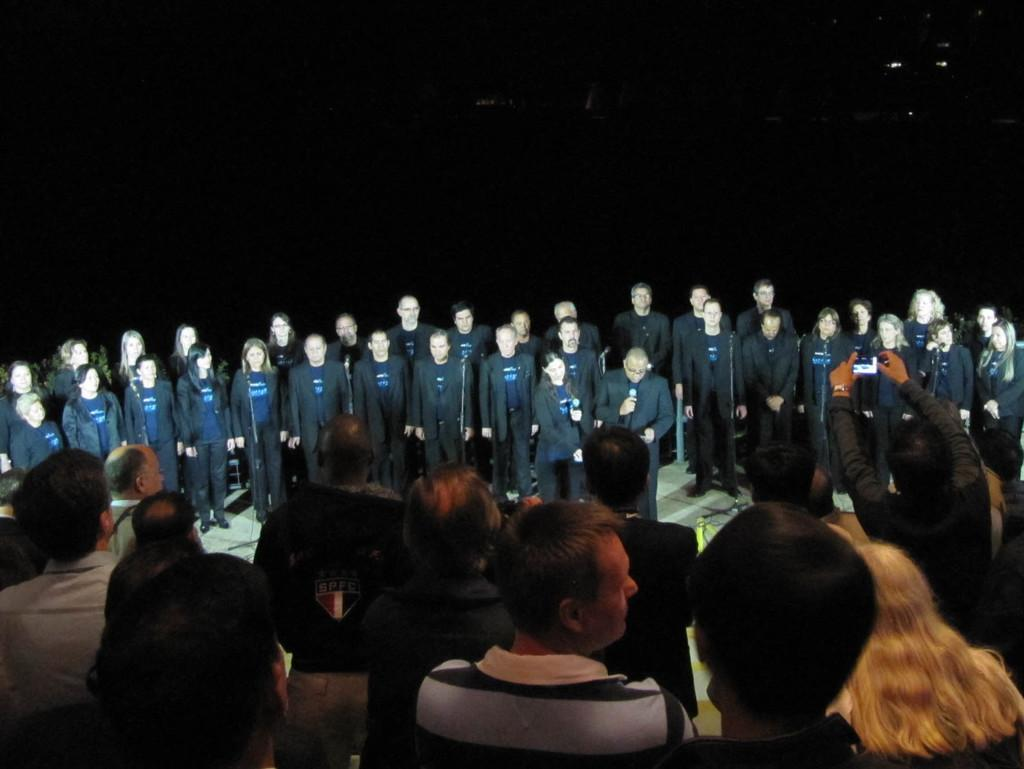What can be seen in the foreground of the picture? There are audience members in the foreground of the picture. What are the people wearing in the center of the picture? There are people wearing black suits in the center of the picture. What objects are present in the image that are used for amplifying sound? There are microphones present in the image. How would you describe the lighting conditions in the background of the image? The background of the image is dark. Can you tell me how many bears are visible in the image? There are no bears present in the image. What type of minister is standing next to the microphone in the image? There is no minister present in the image. 